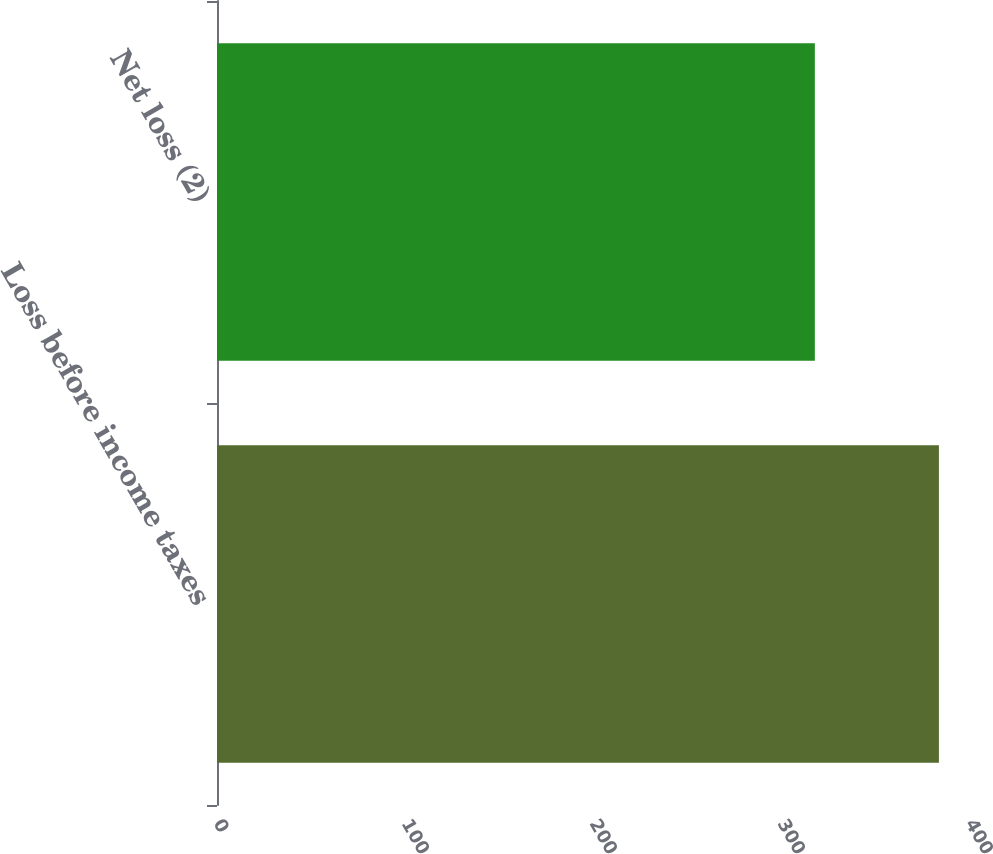Convert chart to OTSL. <chart><loc_0><loc_0><loc_500><loc_500><bar_chart><fcel>Loss before income taxes<fcel>Net loss (2)<nl><fcel>384<fcel>318<nl></chart> 